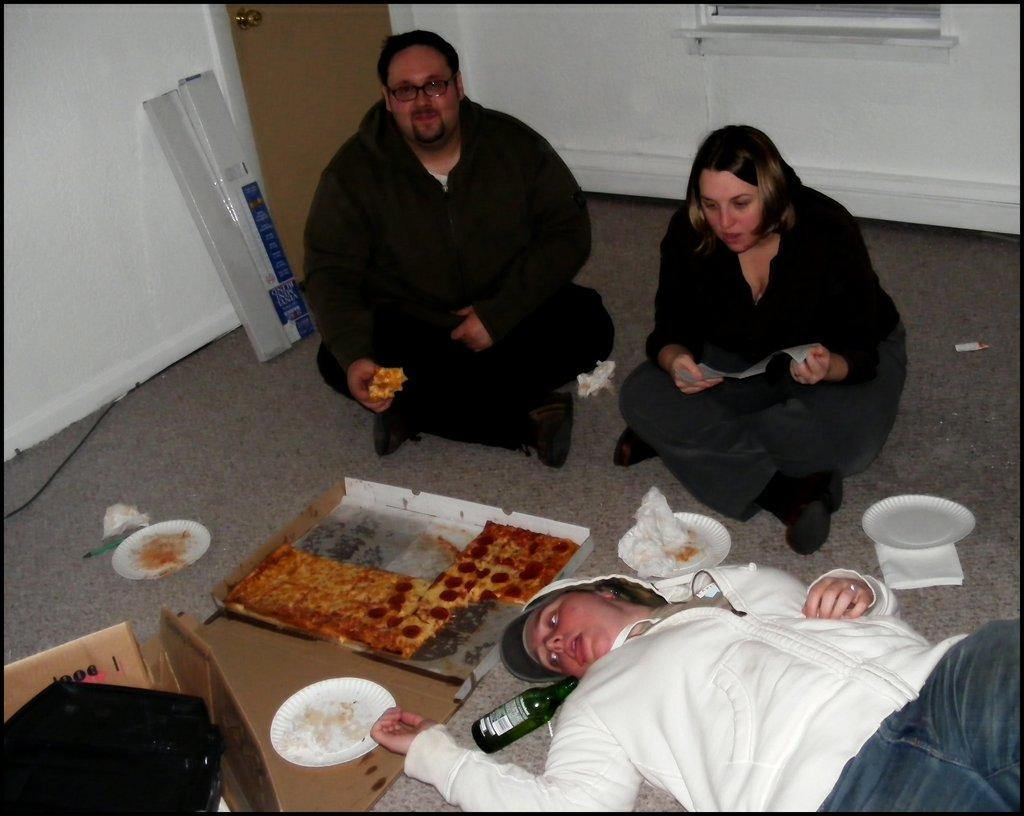What are the two persons in the center of the image doing? The two persons are sitting on the floor in the center of the image. What can be seen at the bottom of the image? There is a person, a bottle, pizza, and a plate at the bottom of the image. What architectural features are visible in the background of the image? There is a wall, a window, and a door in the background of the image. What type of glove is being used by the baby in the image? There is no baby present in the image, and therefore no glove can be observed. 